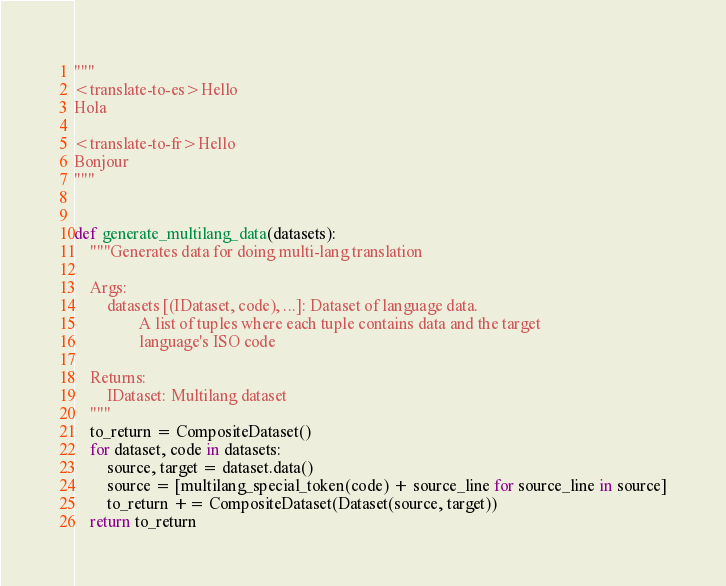<code> <loc_0><loc_0><loc_500><loc_500><_Python_>
"""
<translate-to-es>Hello
Hola

<translate-to-fr>Hello
Bonjour
"""


def generate_multilang_data(datasets):
    """Generates data for doing multi-lang translation

    Args:
        datasets [(IDataset, code), ...]: Dataset of language data.
                A list of tuples where each tuple contains data and the target
                language's ISO code

    Returns:
        IDataset: Multilang dataset
    """
    to_return = CompositeDataset()
    for dataset, code in datasets:
        source, target = dataset.data()
        source = [multilang_special_token(code) + source_line for source_line in source]
        to_return += CompositeDataset(Dataset(source, target))
    return to_return
</code> 